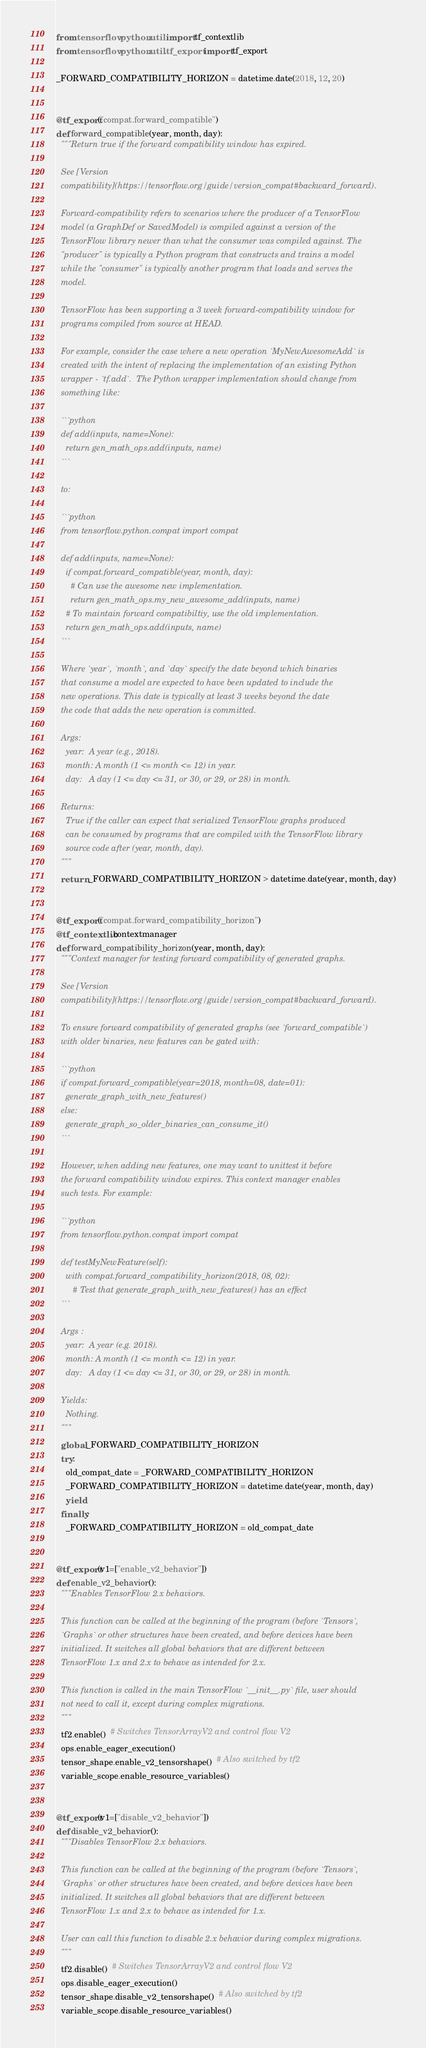Convert code to text. <code><loc_0><loc_0><loc_500><loc_500><_Python_>from tensorflow.python.util import tf_contextlib
from tensorflow.python.util.tf_export import tf_export

_FORWARD_COMPATIBILITY_HORIZON = datetime.date(2018, 12, 20)


@tf_export("compat.forward_compatible")
def forward_compatible(year, month, day):
  """Return true if the forward compatibility window has expired.

  See [Version
  compatibility](https://tensorflow.org/guide/version_compat#backward_forward).

  Forward-compatibility refers to scenarios where the producer of a TensorFlow
  model (a GraphDef or SavedModel) is compiled against a version of the
  TensorFlow library newer than what the consumer was compiled against. The
  "producer" is typically a Python program that constructs and trains a model
  while the "consumer" is typically another program that loads and serves the
  model.

  TensorFlow has been supporting a 3 week forward-compatibility window for
  programs compiled from source at HEAD.

  For example, consider the case where a new operation `MyNewAwesomeAdd` is
  created with the intent of replacing the implementation of an existing Python
  wrapper - `tf.add`.  The Python wrapper implementation should change from
  something like:

  ```python
  def add(inputs, name=None):
    return gen_math_ops.add(inputs, name)
  ```

  to:

  ```python
  from tensorflow.python.compat import compat

  def add(inputs, name=None):
    if compat.forward_compatible(year, month, day):
      # Can use the awesome new implementation.
      return gen_math_ops.my_new_awesome_add(inputs, name)
    # To maintain forward compatibiltiy, use the old implementation.
    return gen_math_ops.add(inputs, name)
  ```

  Where `year`, `month`, and `day` specify the date beyond which binaries
  that consume a model are expected to have been updated to include the
  new operations. This date is typically at least 3 weeks beyond the date
  the code that adds the new operation is committed.

  Args:
    year:  A year (e.g., 2018).
    month: A month (1 <= month <= 12) in year.
    day:   A day (1 <= day <= 31, or 30, or 29, or 28) in month.

  Returns:
    True if the caller can expect that serialized TensorFlow graphs produced
    can be consumed by programs that are compiled with the TensorFlow library
    source code after (year, month, day).
  """
  return _FORWARD_COMPATIBILITY_HORIZON > datetime.date(year, month, day)


@tf_export("compat.forward_compatibility_horizon")
@tf_contextlib.contextmanager
def forward_compatibility_horizon(year, month, day):
  """Context manager for testing forward compatibility of generated graphs.

  See [Version
  compatibility](https://tensorflow.org/guide/version_compat#backward_forward).

  To ensure forward compatibility of generated graphs (see `forward_compatible`)
  with older binaries, new features can be gated with:

  ```python
  if compat.forward_compatible(year=2018, month=08, date=01):
    generate_graph_with_new_features()
  else:
    generate_graph_so_older_binaries_can_consume_it()
  ```

  However, when adding new features, one may want to unittest it before
  the forward compatibility window expires. This context manager enables
  such tests. For example:

  ```python
  from tensorflow.python.compat import compat

  def testMyNewFeature(self):
    with compat.forward_compatibility_horizon(2018, 08, 02):
       # Test that generate_graph_with_new_features() has an effect
  ```

  Args :
    year:  A year (e.g. 2018).
    month: A month (1 <= month <= 12) in year.
    day:   A day (1 <= day <= 31, or 30, or 29, or 28) in month.

  Yields:
    Nothing.
  """
  global _FORWARD_COMPATIBILITY_HORIZON
  try:
    old_compat_date = _FORWARD_COMPATIBILITY_HORIZON
    _FORWARD_COMPATIBILITY_HORIZON = datetime.date(year, month, day)
    yield
  finally:
    _FORWARD_COMPATIBILITY_HORIZON = old_compat_date


@tf_export(v1=["enable_v2_behavior"])
def enable_v2_behavior():
  """Enables TensorFlow 2.x behaviors.

  This function can be called at the beginning of the program (before `Tensors`,
  `Graphs` or other structures have been created, and before devices have been
  initialized. It switches all global behaviors that are different between
  TensorFlow 1.x and 2.x to behave as intended for 2.x.

  This function is called in the main TensorFlow `__init__.py` file, user should
  not need to call it, except during complex migrations.
  """
  tf2.enable()  # Switches TensorArrayV2 and control flow V2
  ops.enable_eager_execution()
  tensor_shape.enable_v2_tensorshape()  # Also switched by tf2
  variable_scope.enable_resource_variables()


@tf_export(v1=["disable_v2_behavior"])
def disable_v2_behavior():
  """Disables TensorFlow 2.x behaviors.

  This function can be called at the beginning of the program (before `Tensors`,
  `Graphs` or other structures have been created, and before devices have been
  initialized. It switches all global behaviors that are different between
  TensorFlow 1.x and 2.x to behave as intended for 1.x.

  User can call this function to disable 2.x behavior during complex migrations.
  """
  tf2.disable()  # Switches TensorArrayV2 and control flow V2
  ops.disable_eager_execution()
  tensor_shape.disable_v2_tensorshape()  # Also switched by tf2
  variable_scope.disable_resource_variables()


</code> 